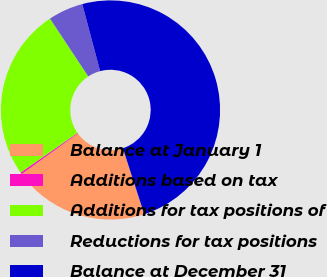Convert chart. <chart><loc_0><loc_0><loc_500><loc_500><pie_chart><fcel>Balance at January 1<fcel>Additions based on tax<fcel>Additions for tax positions of<fcel>Reductions for tax positions<fcel>Balance at December 31<nl><fcel>20.04%<fcel>0.27%<fcel>25.38%<fcel>5.16%<fcel>49.16%<nl></chart> 